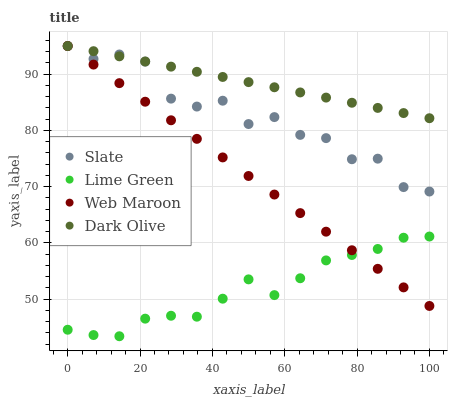Does Lime Green have the minimum area under the curve?
Answer yes or no. Yes. Does Dark Olive have the maximum area under the curve?
Answer yes or no. Yes. Does Slate have the minimum area under the curve?
Answer yes or no. No. Does Slate have the maximum area under the curve?
Answer yes or no. No. Is Web Maroon the smoothest?
Answer yes or no. Yes. Is Slate the roughest?
Answer yes or no. Yes. Is Dark Olive the smoothest?
Answer yes or no. No. Is Dark Olive the roughest?
Answer yes or no. No. Does Lime Green have the lowest value?
Answer yes or no. Yes. Does Slate have the lowest value?
Answer yes or no. No. Does Dark Olive have the highest value?
Answer yes or no. Yes. Does Lime Green have the highest value?
Answer yes or no. No. Is Lime Green less than Slate?
Answer yes or no. Yes. Is Slate greater than Lime Green?
Answer yes or no. Yes. Does Slate intersect Web Maroon?
Answer yes or no. Yes. Is Slate less than Web Maroon?
Answer yes or no. No. Is Slate greater than Web Maroon?
Answer yes or no. No. Does Lime Green intersect Slate?
Answer yes or no. No. 